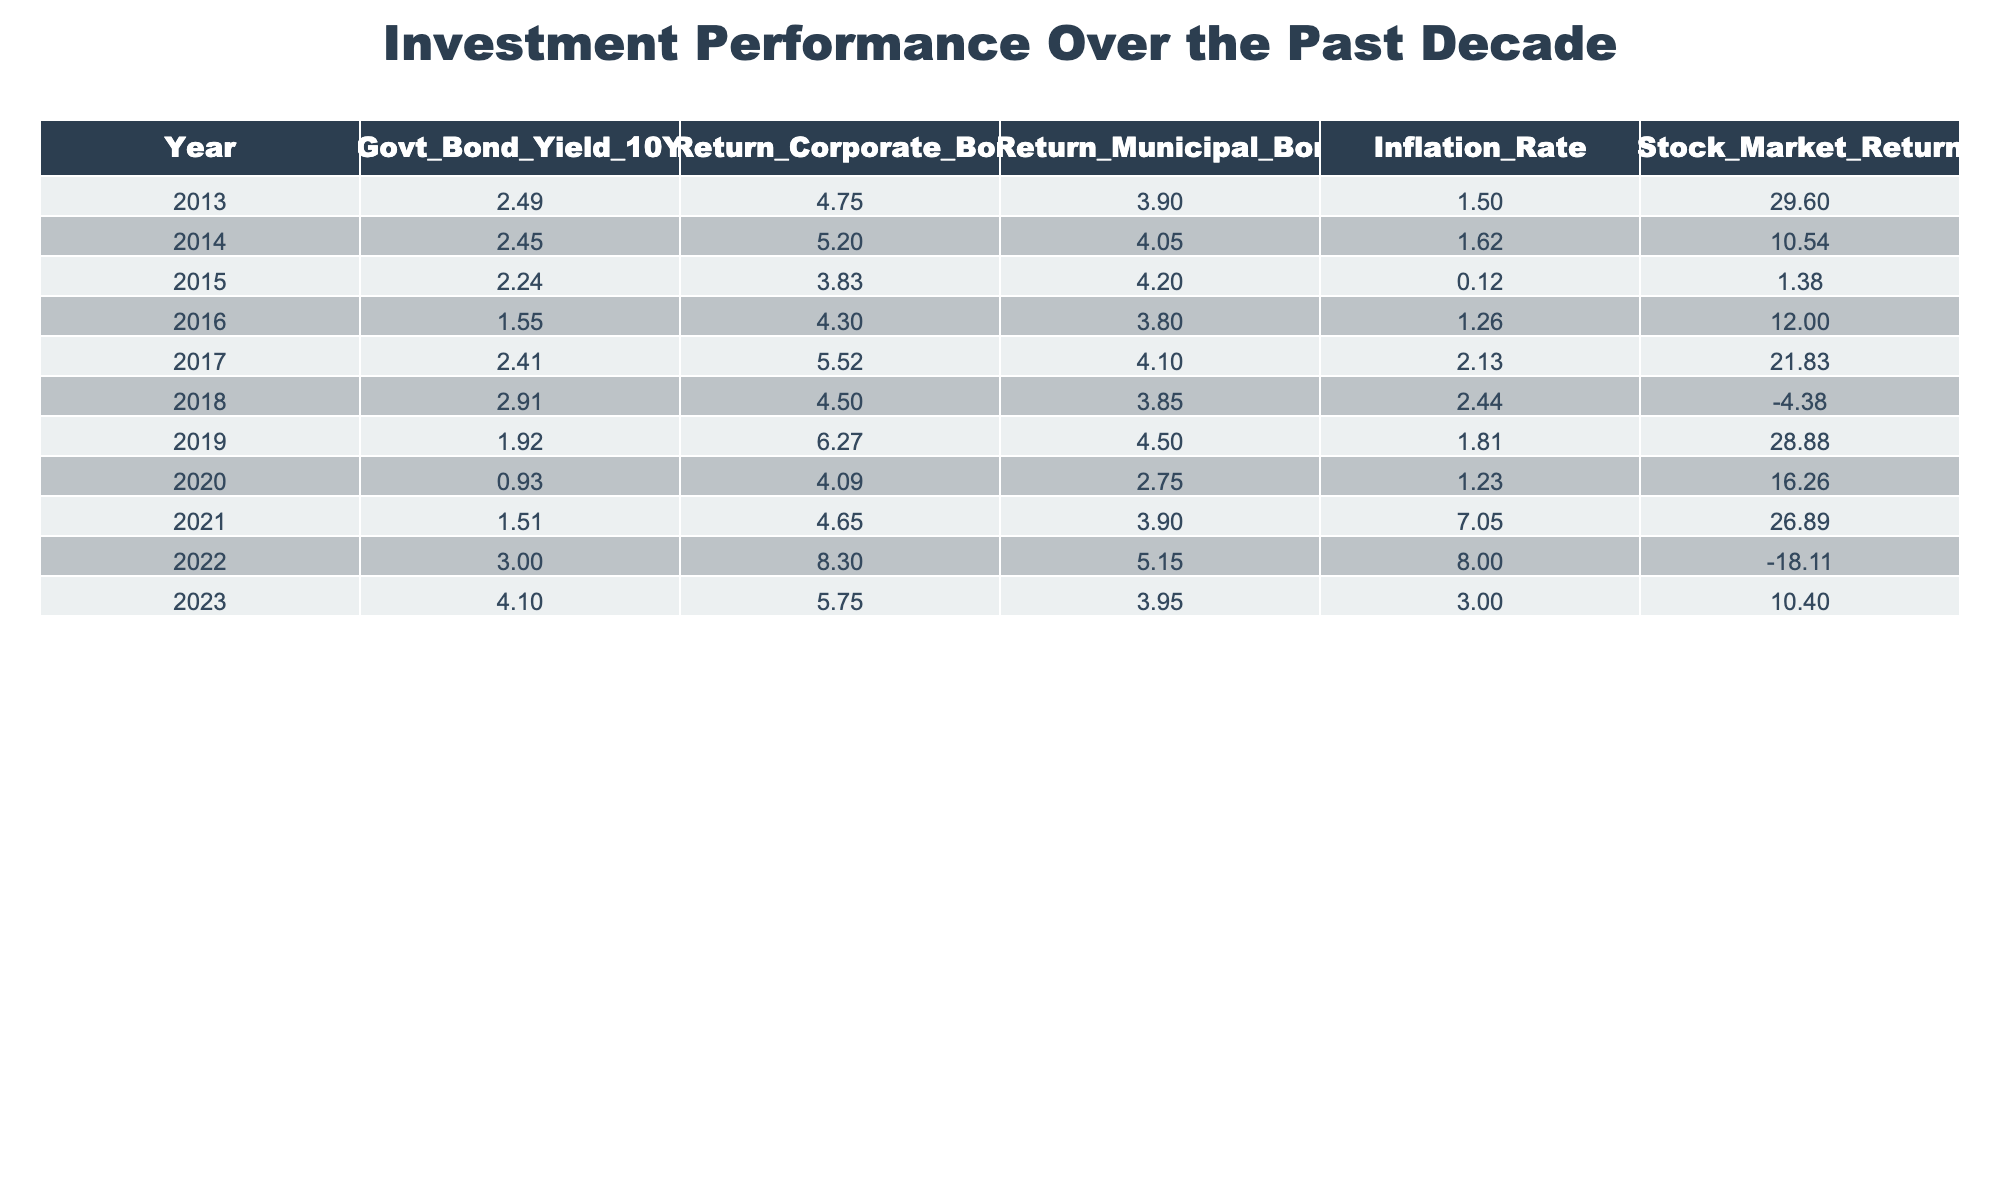What was the highest government bond yield in the past decade? The highest government bond yield in the table is 4.10%, recorded in 2023.
Answer: 4.10% Which year had the lowest return from corporate bonds? The year with the lowest return from corporate bonds is 2015, which had a return of 3.83%.
Answer: 2015 What was the average return of municipal bonds over the last decade? To find the average return of municipal bonds, sum up the returns: (3.90 + 4.05 + 4.20 + 3.80 + 4.10 + 3.85 + 4.50 + 2.75 + 3.90 + 5.15 + 3.95) = 43.25. There are 11 years, so the average return is 43.25 / 11 = 3.93%.
Answer: 3.93% Did inflation exceed the government bond yield in 2022? In 2022, the inflation rate was 8.00%, which significantly exceeds the government bond yield of 3.00%. Therefore, yes, inflation exceeded the yield.
Answer: Yes What is the difference in the return on corporate bonds between 2021 and 2022? The return on corporate bonds in 2021 was 4.65% and in 2022 it was 8.30%. The difference is 8.30 - 4.65 = 3.65%.
Answer: 3.65% 